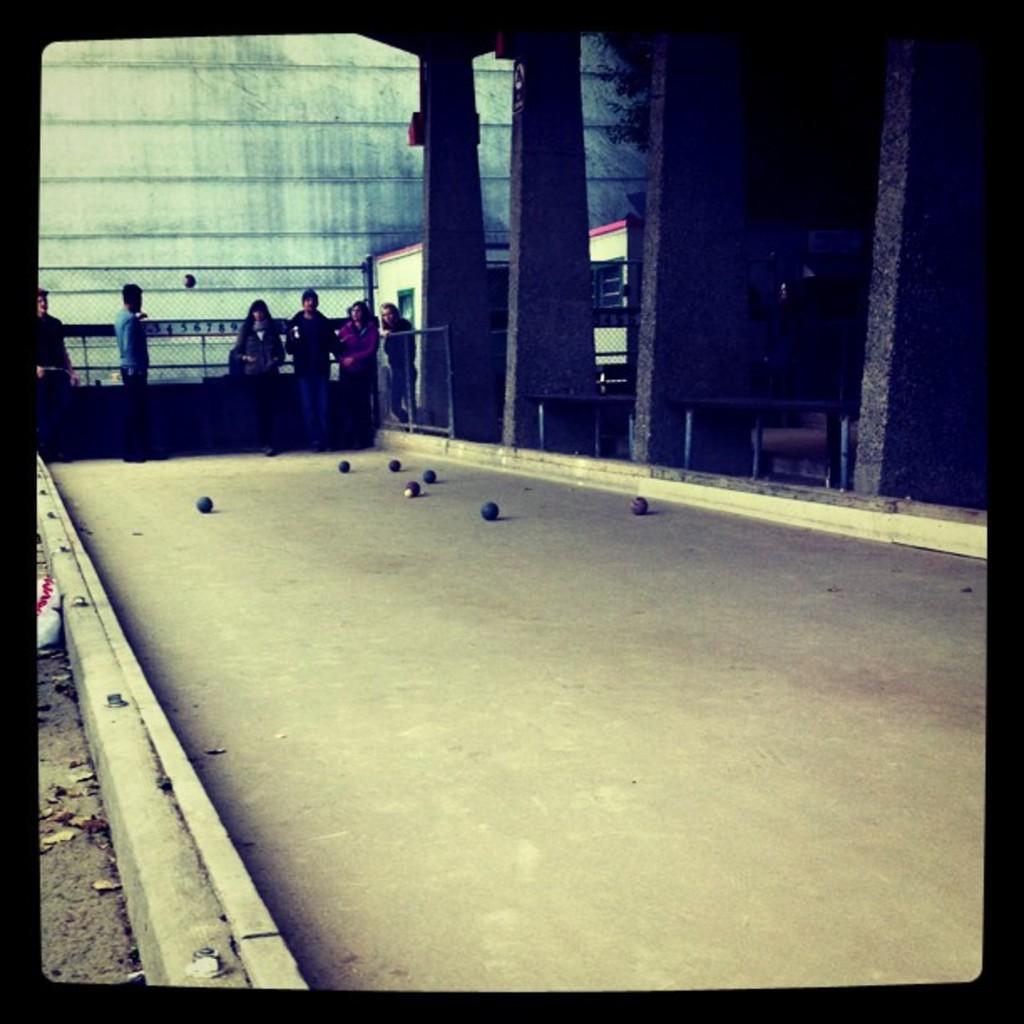Could you give a brief overview of what you see in this image? In this image we can see a few people standing, in front of them, there are some balls, also we can see some pillars, buildings, fence and the wall. 